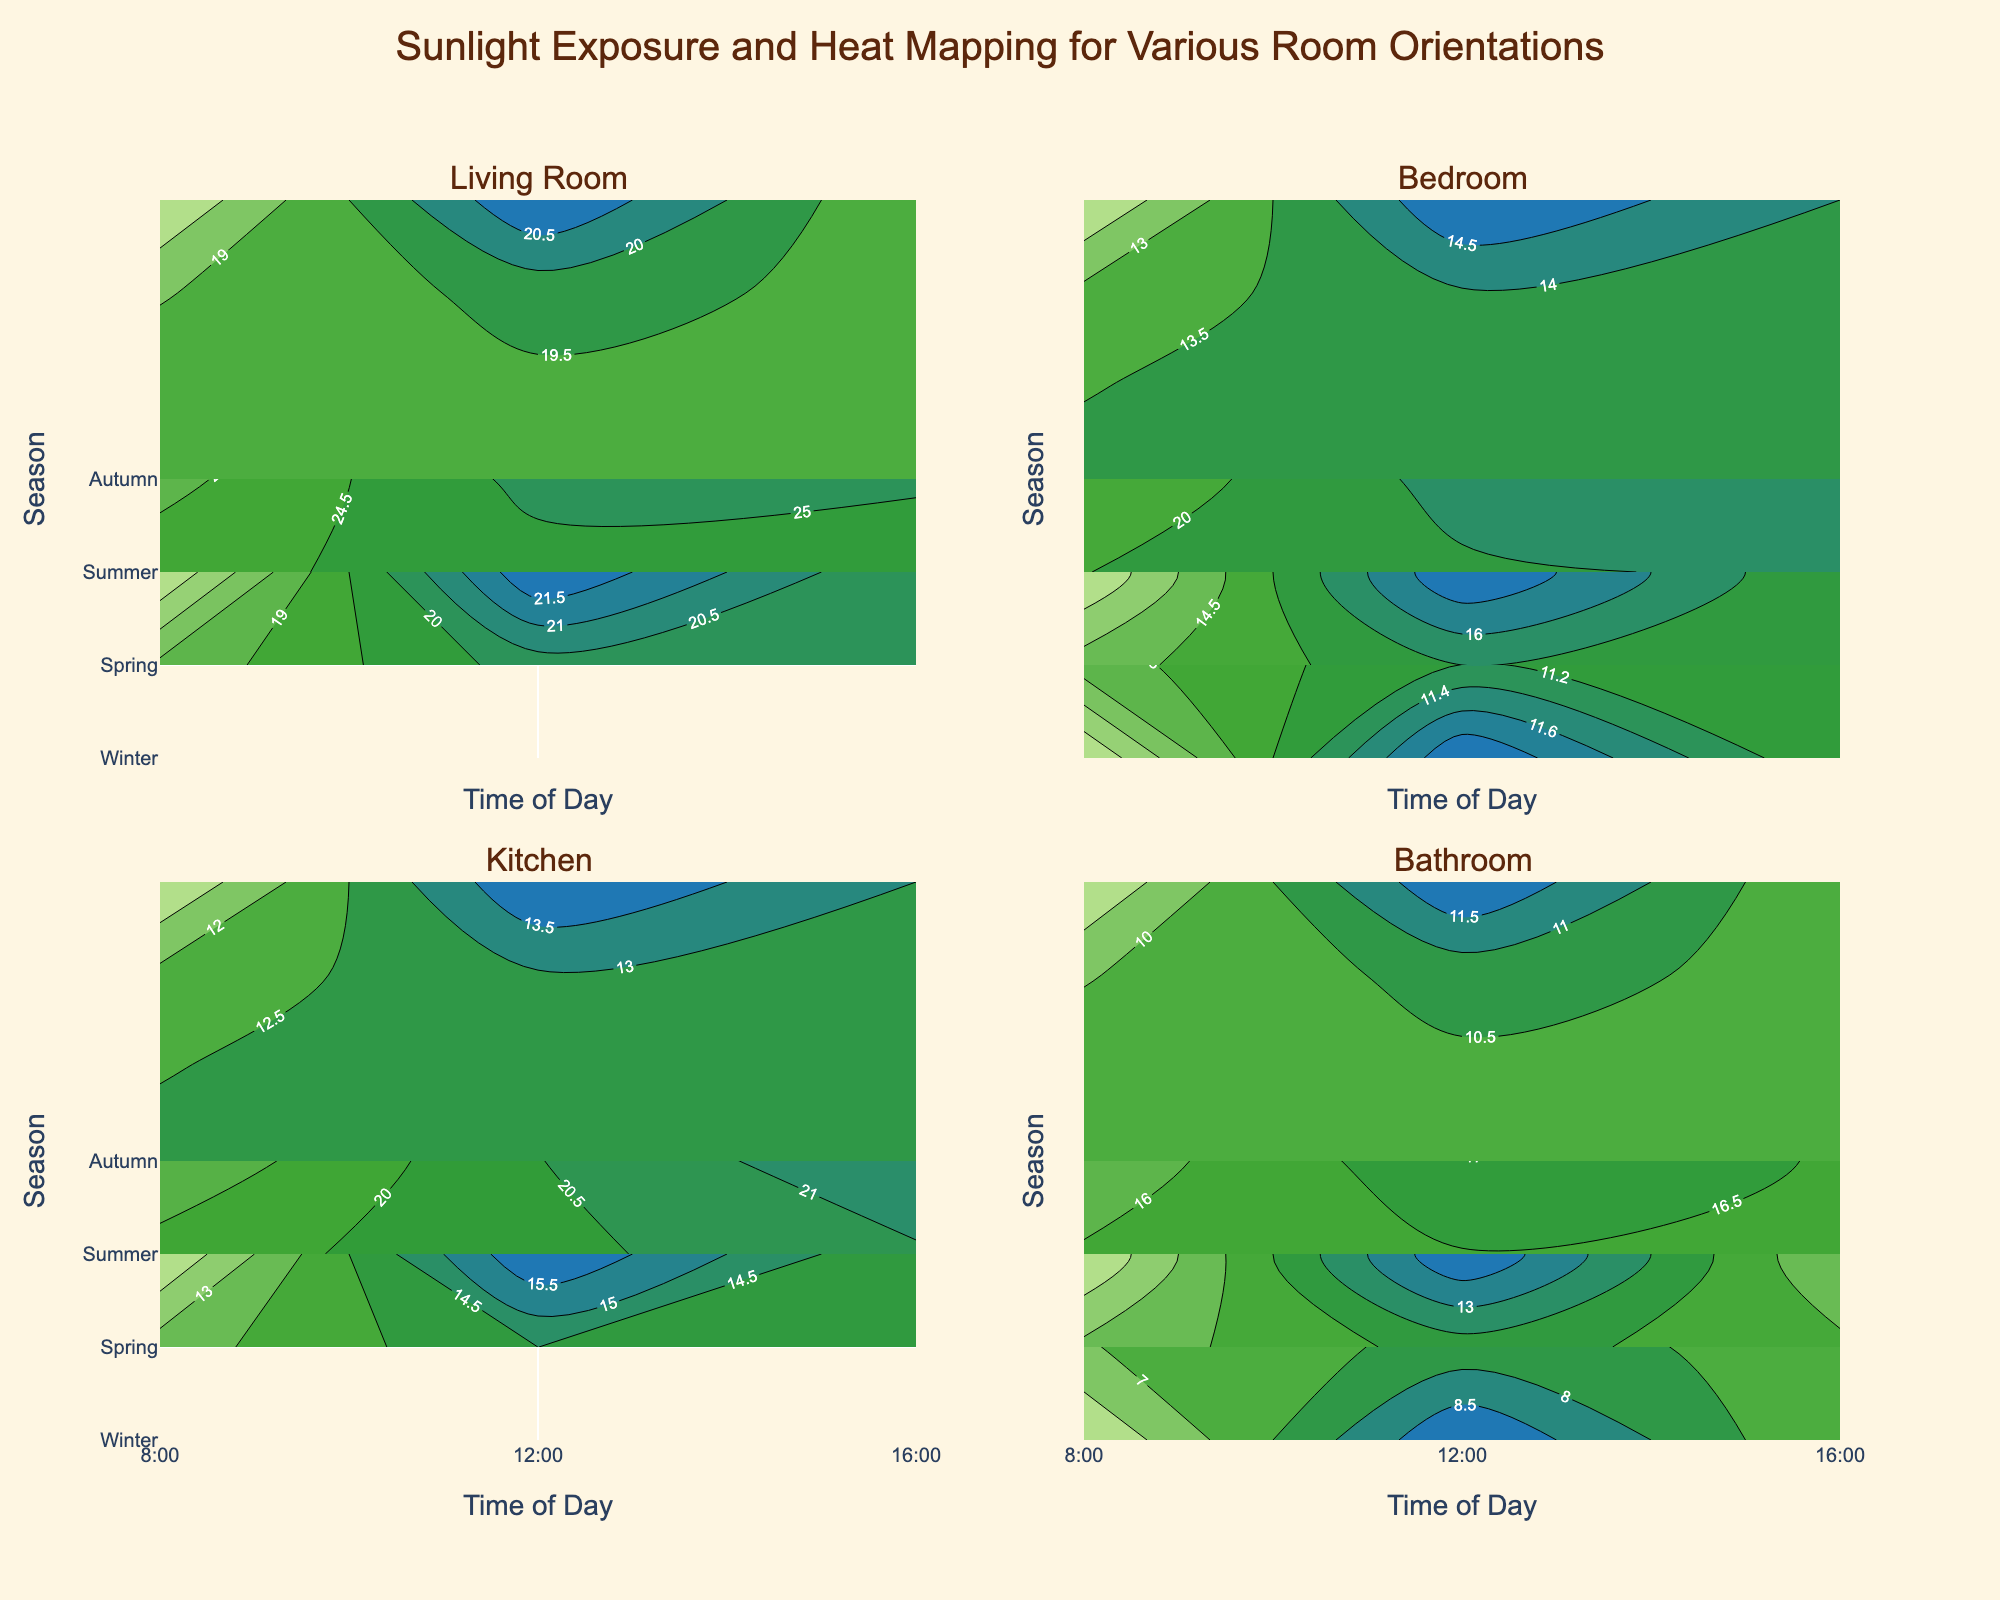What is the title of the figure? The title is generally located at the top center of the figure, written in a larger font size and often bold to make it stand out. From the provided code, we know the title text is specified.
Answer: Sunlight Exposure and Heat Mapping for Various Room Orientations Which room has the highest average sunlight intensity in summer at noon? To solve this, identify the summer season data at 12:00 for each room and sum up the sunlight intensity values. Then, divide by the number of data points to get the average.
Answer: Living Room During which season does the Kitchen experience the highest temperature at 4 pm? Locate the temperature data for the Kitchen in different seasons at 16:00. Compare the values to determine the highest temperature.
Answer: Summer How does the sunlight intensity in the Bathroom compare in winter and spring at 8 a.m.? Extract the sunlight intensity values in the Bathroom at 8:00 in both winter and spring from the data. Comparing these values will show the difference or similarity.
Answer: Higher in Spring Which room shows a more significant increase in temperature from winter to summer at noon: Bedroom or Bathroom? Retrieve temperature data for both rooms at 12:00 during winter and summer. Calculate the difference between winter and summer temperatures for each room and compare these differences.
Answer: Bedroom Is the overall trend of sunlight intensity higher in the morning or afternoon across the rooms and seasons? Compare the sunlight intensity values across different rooms and seasons between morning (8:00) and afternoon (16:00). Add up the values for a general trend analysis.
Answer: Afternoon What is the color pattern indicating higher sunlight intensity and temperature in the contour plots? The color scales used in the contour plot provide this information. Higher sunlight intensities are associated with warmer colors like yellows, while higher temperatures are indicated by richer greens to blues.
Answer: Yellow and Green/Blue Which season has the most balanced sunlight exposure in the Bedroom throughout the day? Check the sunlight intensities in the Bedroom at 8:00, 12:00, and 16:00 across different seasons. Seasonal data with the least variation in values is considered most balanced.
Answer: Autumn What time of day generally shows the peak temperature for the Kitchen across different seasons? Review the temperature contour plots for the Kitchen at 8:00, 12:00, and 16:00 across the seasons, identifying the time showing consistently high temperatures.
Answer: 16:00 